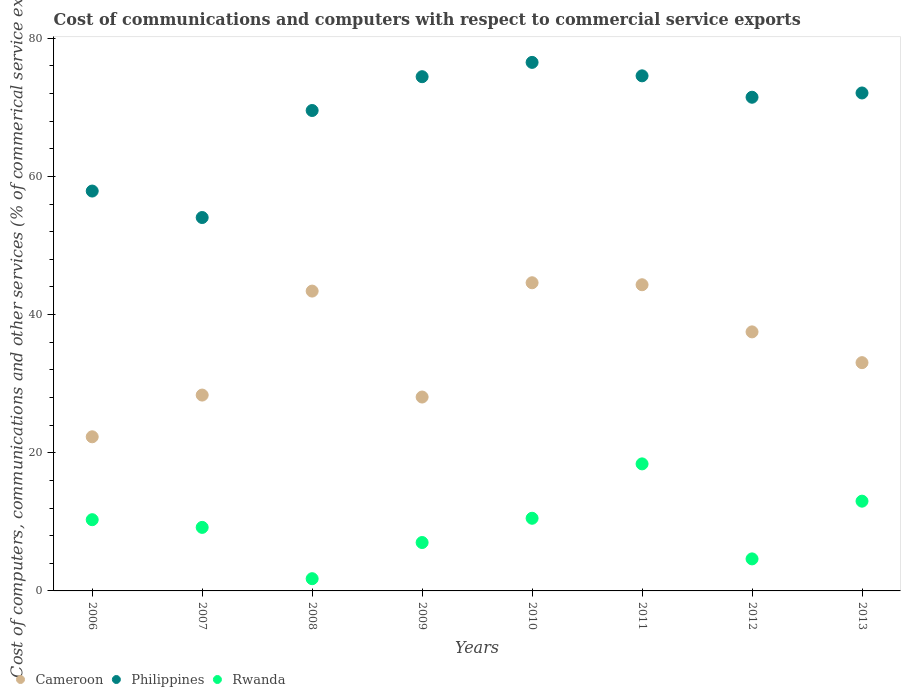What is the cost of communications and computers in Philippines in 2013?
Your answer should be compact. 72.08. Across all years, what is the maximum cost of communications and computers in Rwanda?
Offer a very short reply. 18.39. Across all years, what is the minimum cost of communications and computers in Cameroon?
Give a very brief answer. 22.31. In which year was the cost of communications and computers in Rwanda maximum?
Keep it short and to the point. 2011. What is the total cost of communications and computers in Rwanda in the graph?
Give a very brief answer. 74.81. What is the difference between the cost of communications and computers in Cameroon in 2011 and that in 2013?
Your response must be concise. 11.28. What is the difference between the cost of communications and computers in Philippines in 2011 and the cost of communications and computers in Cameroon in 2007?
Provide a short and direct response. 46.21. What is the average cost of communications and computers in Philippines per year?
Your response must be concise. 68.81. In the year 2011, what is the difference between the cost of communications and computers in Rwanda and cost of communications and computers in Philippines?
Provide a succinct answer. -56.17. What is the ratio of the cost of communications and computers in Philippines in 2006 to that in 2010?
Provide a short and direct response. 0.76. What is the difference between the highest and the second highest cost of communications and computers in Cameroon?
Your answer should be very brief. 0.29. What is the difference between the highest and the lowest cost of communications and computers in Rwanda?
Make the answer very short. 16.62. In how many years, is the cost of communications and computers in Rwanda greater than the average cost of communications and computers in Rwanda taken over all years?
Your response must be concise. 4. Is the sum of the cost of communications and computers in Philippines in 2009 and 2013 greater than the maximum cost of communications and computers in Cameroon across all years?
Ensure brevity in your answer.  Yes. Does the cost of communications and computers in Philippines monotonically increase over the years?
Your answer should be compact. No. Is the cost of communications and computers in Cameroon strictly less than the cost of communications and computers in Philippines over the years?
Your answer should be compact. Yes. What is the difference between two consecutive major ticks on the Y-axis?
Make the answer very short. 20. Does the graph contain any zero values?
Your answer should be compact. No. What is the title of the graph?
Your answer should be compact. Cost of communications and computers with respect to commercial service exports. Does "Low & middle income" appear as one of the legend labels in the graph?
Offer a terse response. No. What is the label or title of the Y-axis?
Ensure brevity in your answer.  Cost of computers, communications and other services (% of commerical service exports). What is the Cost of computers, communications and other services (% of commerical service exports) of Cameroon in 2006?
Offer a terse response. 22.31. What is the Cost of computers, communications and other services (% of commerical service exports) in Philippines in 2006?
Keep it short and to the point. 57.88. What is the Cost of computers, communications and other services (% of commerical service exports) in Rwanda in 2006?
Make the answer very short. 10.31. What is the Cost of computers, communications and other services (% of commerical service exports) in Cameroon in 2007?
Offer a very short reply. 28.35. What is the Cost of computers, communications and other services (% of commerical service exports) in Philippines in 2007?
Offer a very short reply. 54.05. What is the Cost of computers, communications and other services (% of commerical service exports) in Rwanda in 2007?
Keep it short and to the point. 9.2. What is the Cost of computers, communications and other services (% of commerical service exports) in Cameroon in 2008?
Your answer should be very brief. 43.4. What is the Cost of computers, communications and other services (% of commerical service exports) of Philippines in 2008?
Offer a very short reply. 69.54. What is the Cost of computers, communications and other services (% of commerical service exports) in Rwanda in 2008?
Your answer should be compact. 1.77. What is the Cost of computers, communications and other services (% of commerical service exports) in Cameroon in 2009?
Make the answer very short. 28.06. What is the Cost of computers, communications and other services (% of commerical service exports) in Philippines in 2009?
Give a very brief answer. 74.43. What is the Cost of computers, communications and other services (% of commerical service exports) in Rwanda in 2009?
Offer a terse response. 7.01. What is the Cost of computers, communications and other services (% of commerical service exports) in Cameroon in 2010?
Keep it short and to the point. 44.61. What is the Cost of computers, communications and other services (% of commerical service exports) in Philippines in 2010?
Keep it short and to the point. 76.5. What is the Cost of computers, communications and other services (% of commerical service exports) in Rwanda in 2010?
Offer a very short reply. 10.52. What is the Cost of computers, communications and other services (% of commerical service exports) of Cameroon in 2011?
Your response must be concise. 44.32. What is the Cost of computers, communications and other services (% of commerical service exports) of Philippines in 2011?
Your answer should be very brief. 74.56. What is the Cost of computers, communications and other services (% of commerical service exports) in Rwanda in 2011?
Offer a terse response. 18.39. What is the Cost of computers, communications and other services (% of commerical service exports) in Cameroon in 2012?
Give a very brief answer. 37.5. What is the Cost of computers, communications and other services (% of commerical service exports) in Philippines in 2012?
Provide a short and direct response. 71.46. What is the Cost of computers, communications and other services (% of commerical service exports) in Rwanda in 2012?
Provide a succinct answer. 4.64. What is the Cost of computers, communications and other services (% of commerical service exports) in Cameroon in 2013?
Provide a short and direct response. 33.04. What is the Cost of computers, communications and other services (% of commerical service exports) of Philippines in 2013?
Ensure brevity in your answer.  72.08. What is the Cost of computers, communications and other services (% of commerical service exports) of Rwanda in 2013?
Offer a terse response. 12.99. Across all years, what is the maximum Cost of computers, communications and other services (% of commerical service exports) in Cameroon?
Provide a short and direct response. 44.61. Across all years, what is the maximum Cost of computers, communications and other services (% of commerical service exports) of Philippines?
Make the answer very short. 76.5. Across all years, what is the maximum Cost of computers, communications and other services (% of commerical service exports) of Rwanda?
Provide a short and direct response. 18.39. Across all years, what is the minimum Cost of computers, communications and other services (% of commerical service exports) of Cameroon?
Keep it short and to the point. 22.31. Across all years, what is the minimum Cost of computers, communications and other services (% of commerical service exports) of Philippines?
Your response must be concise. 54.05. Across all years, what is the minimum Cost of computers, communications and other services (% of commerical service exports) of Rwanda?
Provide a short and direct response. 1.77. What is the total Cost of computers, communications and other services (% of commerical service exports) in Cameroon in the graph?
Offer a terse response. 281.59. What is the total Cost of computers, communications and other services (% of commerical service exports) of Philippines in the graph?
Your answer should be compact. 550.5. What is the total Cost of computers, communications and other services (% of commerical service exports) in Rwanda in the graph?
Offer a terse response. 74.81. What is the difference between the Cost of computers, communications and other services (% of commerical service exports) in Cameroon in 2006 and that in 2007?
Give a very brief answer. -6.04. What is the difference between the Cost of computers, communications and other services (% of commerical service exports) in Philippines in 2006 and that in 2007?
Ensure brevity in your answer.  3.83. What is the difference between the Cost of computers, communications and other services (% of commerical service exports) of Rwanda in 2006 and that in 2007?
Make the answer very short. 1.11. What is the difference between the Cost of computers, communications and other services (% of commerical service exports) of Cameroon in 2006 and that in 2008?
Keep it short and to the point. -21.09. What is the difference between the Cost of computers, communications and other services (% of commerical service exports) in Philippines in 2006 and that in 2008?
Keep it short and to the point. -11.66. What is the difference between the Cost of computers, communications and other services (% of commerical service exports) in Rwanda in 2006 and that in 2008?
Ensure brevity in your answer.  8.54. What is the difference between the Cost of computers, communications and other services (% of commerical service exports) of Cameroon in 2006 and that in 2009?
Provide a short and direct response. -5.75. What is the difference between the Cost of computers, communications and other services (% of commerical service exports) of Philippines in 2006 and that in 2009?
Provide a short and direct response. -16.55. What is the difference between the Cost of computers, communications and other services (% of commerical service exports) of Rwanda in 2006 and that in 2009?
Keep it short and to the point. 3.3. What is the difference between the Cost of computers, communications and other services (% of commerical service exports) of Cameroon in 2006 and that in 2010?
Give a very brief answer. -22.3. What is the difference between the Cost of computers, communications and other services (% of commerical service exports) in Philippines in 2006 and that in 2010?
Your answer should be compact. -18.62. What is the difference between the Cost of computers, communications and other services (% of commerical service exports) in Rwanda in 2006 and that in 2010?
Offer a terse response. -0.21. What is the difference between the Cost of computers, communications and other services (% of commerical service exports) in Cameroon in 2006 and that in 2011?
Give a very brief answer. -22.01. What is the difference between the Cost of computers, communications and other services (% of commerical service exports) of Philippines in 2006 and that in 2011?
Provide a short and direct response. -16.68. What is the difference between the Cost of computers, communications and other services (% of commerical service exports) in Rwanda in 2006 and that in 2011?
Keep it short and to the point. -8.08. What is the difference between the Cost of computers, communications and other services (% of commerical service exports) in Cameroon in 2006 and that in 2012?
Provide a succinct answer. -15.19. What is the difference between the Cost of computers, communications and other services (% of commerical service exports) of Philippines in 2006 and that in 2012?
Your response must be concise. -13.58. What is the difference between the Cost of computers, communications and other services (% of commerical service exports) in Rwanda in 2006 and that in 2012?
Make the answer very short. 5.67. What is the difference between the Cost of computers, communications and other services (% of commerical service exports) in Cameroon in 2006 and that in 2013?
Provide a succinct answer. -10.73. What is the difference between the Cost of computers, communications and other services (% of commerical service exports) in Philippines in 2006 and that in 2013?
Your answer should be compact. -14.2. What is the difference between the Cost of computers, communications and other services (% of commerical service exports) in Rwanda in 2006 and that in 2013?
Provide a short and direct response. -2.68. What is the difference between the Cost of computers, communications and other services (% of commerical service exports) in Cameroon in 2007 and that in 2008?
Make the answer very short. -15.05. What is the difference between the Cost of computers, communications and other services (% of commerical service exports) in Philippines in 2007 and that in 2008?
Your answer should be compact. -15.49. What is the difference between the Cost of computers, communications and other services (% of commerical service exports) of Rwanda in 2007 and that in 2008?
Keep it short and to the point. 7.43. What is the difference between the Cost of computers, communications and other services (% of commerical service exports) in Cameroon in 2007 and that in 2009?
Your response must be concise. 0.28. What is the difference between the Cost of computers, communications and other services (% of commerical service exports) in Philippines in 2007 and that in 2009?
Offer a very short reply. -20.38. What is the difference between the Cost of computers, communications and other services (% of commerical service exports) in Rwanda in 2007 and that in 2009?
Make the answer very short. 2.19. What is the difference between the Cost of computers, communications and other services (% of commerical service exports) in Cameroon in 2007 and that in 2010?
Make the answer very short. -16.26. What is the difference between the Cost of computers, communications and other services (% of commerical service exports) in Philippines in 2007 and that in 2010?
Your answer should be very brief. -22.46. What is the difference between the Cost of computers, communications and other services (% of commerical service exports) in Rwanda in 2007 and that in 2010?
Offer a very short reply. -1.32. What is the difference between the Cost of computers, communications and other services (% of commerical service exports) of Cameroon in 2007 and that in 2011?
Ensure brevity in your answer.  -15.97. What is the difference between the Cost of computers, communications and other services (% of commerical service exports) of Philippines in 2007 and that in 2011?
Provide a short and direct response. -20.51. What is the difference between the Cost of computers, communications and other services (% of commerical service exports) in Rwanda in 2007 and that in 2011?
Provide a succinct answer. -9.19. What is the difference between the Cost of computers, communications and other services (% of commerical service exports) of Cameroon in 2007 and that in 2012?
Your answer should be very brief. -9.15. What is the difference between the Cost of computers, communications and other services (% of commerical service exports) of Philippines in 2007 and that in 2012?
Keep it short and to the point. -17.41. What is the difference between the Cost of computers, communications and other services (% of commerical service exports) in Rwanda in 2007 and that in 2012?
Your answer should be compact. 4.56. What is the difference between the Cost of computers, communications and other services (% of commerical service exports) in Cameroon in 2007 and that in 2013?
Give a very brief answer. -4.69. What is the difference between the Cost of computers, communications and other services (% of commerical service exports) of Philippines in 2007 and that in 2013?
Your response must be concise. -18.03. What is the difference between the Cost of computers, communications and other services (% of commerical service exports) of Rwanda in 2007 and that in 2013?
Your response must be concise. -3.8. What is the difference between the Cost of computers, communications and other services (% of commerical service exports) of Cameroon in 2008 and that in 2009?
Provide a short and direct response. 15.34. What is the difference between the Cost of computers, communications and other services (% of commerical service exports) in Philippines in 2008 and that in 2009?
Provide a short and direct response. -4.89. What is the difference between the Cost of computers, communications and other services (% of commerical service exports) of Rwanda in 2008 and that in 2009?
Offer a terse response. -5.24. What is the difference between the Cost of computers, communications and other services (% of commerical service exports) of Cameroon in 2008 and that in 2010?
Your response must be concise. -1.21. What is the difference between the Cost of computers, communications and other services (% of commerical service exports) of Philippines in 2008 and that in 2010?
Make the answer very short. -6.96. What is the difference between the Cost of computers, communications and other services (% of commerical service exports) in Rwanda in 2008 and that in 2010?
Ensure brevity in your answer.  -8.75. What is the difference between the Cost of computers, communications and other services (% of commerical service exports) in Cameroon in 2008 and that in 2011?
Provide a succinct answer. -0.92. What is the difference between the Cost of computers, communications and other services (% of commerical service exports) of Philippines in 2008 and that in 2011?
Your answer should be very brief. -5.02. What is the difference between the Cost of computers, communications and other services (% of commerical service exports) in Rwanda in 2008 and that in 2011?
Make the answer very short. -16.62. What is the difference between the Cost of computers, communications and other services (% of commerical service exports) in Cameroon in 2008 and that in 2012?
Make the answer very short. 5.9. What is the difference between the Cost of computers, communications and other services (% of commerical service exports) of Philippines in 2008 and that in 2012?
Offer a very short reply. -1.92. What is the difference between the Cost of computers, communications and other services (% of commerical service exports) of Rwanda in 2008 and that in 2012?
Your answer should be compact. -2.87. What is the difference between the Cost of computers, communications and other services (% of commerical service exports) of Cameroon in 2008 and that in 2013?
Give a very brief answer. 10.36. What is the difference between the Cost of computers, communications and other services (% of commerical service exports) of Philippines in 2008 and that in 2013?
Your response must be concise. -2.54. What is the difference between the Cost of computers, communications and other services (% of commerical service exports) of Rwanda in 2008 and that in 2013?
Offer a very short reply. -11.22. What is the difference between the Cost of computers, communications and other services (% of commerical service exports) of Cameroon in 2009 and that in 2010?
Keep it short and to the point. -16.54. What is the difference between the Cost of computers, communications and other services (% of commerical service exports) in Philippines in 2009 and that in 2010?
Make the answer very short. -2.07. What is the difference between the Cost of computers, communications and other services (% of commerical service exports) of Rwanda in 2009 and that in 2010?
Provide a succinct answer. -3.51. What is the difference between the Cost of computers, communications and other services (% of commerical service exports) of Cameroon in 2009 and that in 2011?
Give a very brief answer. -16.25. What is the difference between the Cost of computers, communications and other services (% of commerical service exports) in Philippines in 2009 and that in 2011?
Offer a terse response. -0.12. What is the difference between the Cost of computers, communications and other services (% of commerical service exports) in Rwanda in 2009 and that in 2011?
Make the answer very short. -11.38. What is the difference between the Cost of computers, communications and other services (% of commerical service exports) of Cameroon in 2009 and that in 2012?
Give a very brief answer. -9.43. What is the difference between the Cost of computers, communications and other services (% of commerical service exports) in Philippines in 2009 and that in 2012?
Give a very brief answer. 2.97. What is the difference between the Cost of computers, communications and other services (% of commerical service exports) of Rwanda in 2009 and that in 2012?
Your answer should be compact. 2.37. What is the difference between the Cost of computers, communications and other services (% of commerical service exports) in Cameroon in 2009 and that in 2013?
Keep it short and to the point. -4.98. What is the difference between the Cost of computers, communications and other services (% of commerical service exports) of Philippines in 2009 and that in 2013?
Provide a short and direct response. 2.36. What is the difference between the Cost of computers, communications and other services (% of commerical service exports) in Rwanda in 2009 and that in 2013?
Provide a succinct answer. -5.99. What is the difference between the Cost of computers, communications and other services (% of commerical service exports) in Cameroon in 2010 and that in 2011?
Give a very brief answer. 0.29. What is the difference between the Cost of computers, communications and other services (% of commerical service exports) in Philippines in 2010 and that in 2011?
Provide a short and direct response. 1.95. What is the difference between the Cost of computers, communications and other services (% of commerical service exports) of Rwanda in 2010 and that in 2011?
Give a very brief answer. -7.87. What is the difference between the Cost of computers, communications and other services (% of commerical service exports) of Cameroon in 2010 and that in 2012?
Keep it short and to the point. 7.11. What is the difference between the Cost of computers, communications and other services (% of commerical service exports) in Philippines in 2010 and that in 2012?
Make the answer very short. 5.04. What is the difference between the Cost of computers, communications and other services (% of commerical service exports) in Rwanda in 2010 and that in 2012?
Make the answer very short. 5.88. What is the difference between the Cost of computers, communications and other services (% of commerical service exports) in Cameroon in 2010 and that in 2013?
Provide a short and direct response. 11.57. What is the difference between the Cost of computers, communications and other services (% of commerical service exports) of Philippines in 2010 and that in 2013?
Offer a terse response. 4.43. What is the difference between the Cost of computers, communications and other services (% of commerical service exports) of Rwanda in 2010 and that in 2013?
Your answer should be very brief. -2.48. What is the difference between the Cost of computers, communications and other services (% of commerical service exports) in Cameroon in 2011 and that in 2012?
Your answer should be compact. 6.82. What is the difference between the Cost of computers, communications and other services (% of commerical service exports) of Philippines in 2011 and that in 2012?
Keep it short and to the point. 3.1. What is the difference between the Cost of computers, communications and other services (% of commerical service exports) of Rwanda in 2011 and that in 2012?
Your response must be concise. 13.75. What is the difference between the Cost of computers, communications and other services (% of commerical service exports) of Cameroon in 2011 and that in 2013?
Ensure brevity in your answer.  11.28. What is the difference between the Cost of computers, communications and other services (% of commerical service exports) of Philippines in 2011 and that in 2013?
Give a very brief answer. 2.48. What is the difference between the Cost of computers, communications and other services (% of commerical service exports) of Rwanda in 2011 and that in 2013?
Provide a succinct answer. 5.4. What is the difference between the Cost of computers, communications and other services (% of commerical service exports) in Cameroon in 2012 and that in 2013?
Provide a short and direct response. 4.45. What is the difference between the Cost of computers, communications and other services (% of commerical service exports) of Philippines in 2012 and that in 2013?
Your answer should be compact. -0.62. What is the difference between the Cost of computers, communications and other services (% of commerical service exports) of Rwanda in 2012 and that in 2013?
Provide a short and direct response. -8.36. What is the difference between the Cost of computers, communications and other services (% of commerical service exports) in Cameroon in 2006 and the Cost of computers, communications and other services (% of commerical service exports) in Philippines in 2007?
Ensure brevity in your answer.  -31.74. What is the difference between the Cost of computers, communications and other services (% of commerical service exports) in Cameroon in 2006 and the Cost of computers, communications and other services (% of commerical service exports) in Rwanda in 2007?
Provide a short and direct response. 13.11. What is the difference between the Cost of computers, communications and other services (% of commerical service exports) in Philippines in 2006 and the Cost of computers, communications and other services (% of commerical service exports) in Rwanda in 2007?
Ensure brevity in your answer.  48.68. What is the difference between the Cost of computers, communications and other services (% of commerical service exports) in Cameroon in 2006 and the Cost of computers, communications and other services (% of commerical service exports) in Philippines in 2008?
Your answer should be compact. -47.23. What is the difference between the Cost of computers, communications and other services (% of commerical service exports) of Cameroon in 2006 and the Cost of computers, communications and other services (% of commerical service exports) of Rwanda in 2008?
Provide a succinct answer. 20.54. What is the difference between the Cost of computers, communications and other services (% of commerical service exports) in Philippines in 2006 and the Cost of computers, communications and other services (% of commerical service exports) in Rwanda in 2008?
Your answer should be compact. 56.11. What is the difference between the Cost of computers, communications and other services (% of commerical service exports) of Cameroon in 2006 and the Cost of computers, communications and other services (% of commerical service exports) of Philippines in 2009?
Keep it short and to the point. -52.12. What is the difference between the Cost of computers, communications and other services (% of commerical service exports) of Cameroon in 2006 and the Cost of computers, communications and other services (% of commerical service exports) of Rwanda in 2009?
Provide a short and direct response. 15.3. What is the difference between the Cost of computers, communications and other services (% of commerical service exports) of Philippines in 2006 and the Cost of computers, communications and other services (% of commerical service exports) of Rwanda in 2009?
Offer a terse response. 50.88. What is the difference between the Cost of computers, communications and other services (% of commerical service exports) of Cameroon in 2006 and the Cost of computers, communications and other services (% of commerical service exports) of Philippines in 2010?
Keep it short and to the point. -54.19. What is the difference between the Cost of computers, communications and other services (% of commerical service exports) in Cameroon in 2006 and the Cost of computers, communications and other services (% of commerical service exports) in Rwanda in 2010?
Make the answer very short. 11.79. What is the difference between the Cost of computers, communications and other services (% of commerical service exports) in Philippines in 2006 and the Cost of computers, communications and other services (% of commerical service exports) in Rwanda in 2010?
Provide a succinct answer. 47.36. What is the difference between the Cost of computers, communications and other services (% of commerical service exports) in Cameroon in 2006 and the Cost of computers, communications and other services (% of commerical service exports) in Philippines in 2011?
Offer a terse response. -52.25. What is the difference between the Cost of computers, communications and other services (% of commerical service exports) of Cameroon in 2006 and the Cost of computers, communications and other services (% of commerical service exports) of Rwanda in 2011?
Your response must be concise. 3.92. What is the difference between the Cost of computers, communications and other services (% of commerical service exports) of Philippines in 2006 and the Cost of computers, communications and other services (% of commerical service exports) of Rwanda in 2011?
Ensure brevity in your answer.  39.49. What is the difference between the Cost of computers, communications and other services (% of commerical service exports) of Cameroon in 2006 and the Cost of computers, communications and other services (% of commerical service exports) of Philippines in 2012?
Your answer should be compact. -49.15. What is the difference between the Cost of computers, communications and other services (% of commerical service exports) in Cameroon in 2006 and the Cost of computers, communications and other services (% of commerical service exports) in Rwanda in 2012?
Your answer should be compact. 17.67. What is the difference between the Cost of computers, communications and other services (% of commerical service exports) of Philippines in 2006 and the Cost of computers, communications and other services (% of commerical service exports) of Rwanda in 2012?
Provide a succinct answer. 53.24. What is the difference between the Cost of computers, communications and other services (% of commerical service exports) of Cameroon in 2006 and the Cost of computers, communications and other services (% of commerical service exports) of Philippines in 2013?
Ensure brevity in your answer.  -49.77. What is the difference between the Cost of computers, communications and other services (% of commerical service exports) in Cameroon in 2006 and the Cost of computers, communications and other services (% of commerical service exports) in Rwanda in 2013?
Your answer should be very brief. 9.32. What is the difference between the Cost of computers, communications and other services (% of commerical service exports) in Philippines in 2006 and the Cost of computers, communications and other services (% of commerical service exports) in Rwanda in 2013?
Give a very brief answer. 44.89. What is the difference between the Cost of computers, communications and other services (% of commerical service exports) of Cameroon in 2007 and the Cost of computers, communications and other services (% of commerical service exports) of Philippines in 2008?
Your answer should be compact. -41.19. What is the difference between the Cost of computers, communications and other services (% of commerical service exports) in Cameroon in 2007 and the Cost of computers, communications and other services (% of commerical service exports) in Rwanda in 2008?
Your answer should be very brief. 26.58. What is the difference between the Cost of computers, communications and other services (% of commerical service exports) in Philippines in 2007 and the Cost of computers, communications and other services (% of commerical service exports) in Rwanda in 2008?
Make the answer very short. 52.28. What is the difference between the Cost of computers, communications and other services (% of commerical service exports) in Cameroon in 2007 and the Cost of computers, communications and other services (% of commerical service exports) in Philippines in 2009?
Provide a succinct answer. -46.08. What is the difference between the Cost of computers, communications and other services (% of commerical service exports) of Cameroon in 2007 and the Cost of computers, communications and other services (% of commerical service exports) of Rwanda in 2009?
Keep it short and to the point. 21.34. What is the difference between the Cost of computers, communications and other services (% of commerical service exports) in Philippines in 2007 and the Cost of computers, communications and other services (% of commerical service exports) in Rwanda in 2009?
Provide a succinct answer. 47.04. What is the difference between the Cost of computers, communications and other services (% of commerical service exports) in Cameroon in 2007 and the Cost of computers, communications and other services (% of commerical service exports) in Philippines in 2010?
Offer a terse response. -48.16. What is the difference between the Cost of computers, communications and other services (% of commerical service exports) of Cameroon in 2007 and the Cost of computers, communications and other services (% of commerical service exports) of Rwanda in 2010?
Your response must be concise. 17.83. What is the difference between the Cost of computers, communications and other services (% of commerical service exports) in Philippines in 2007 and the Cost of computers, communications and other services (% of commerical service exports) in Rwanda in 2010?
Keep it short and to the point. 43.53. What is the difference between the Cost of computers, communications and other services (% of commerical service exports) in Cameroon in 2007 and the Cost of computers, communications and other services (% of commerical service exports) in Philippines in 2011?
Your answer should be compact. -46.21. What is the difference between the Cost of computers, communications and other services (% of commerical service exports) in Cameroon in 2007 and the Cost of computers, communications and other services (% of commerical service exports) in Rwanda in 2011?
Ensure brevity in your answer.  9.96. What is the difference between the Cost of computers, communications and other services (% of commerical service exports) in Philippines in 2007 and the Cost of computers, communications and other services (% of commerical service exports) in Rwanda in 2011?
Make the answer very short. 35.66. What is the difference between the Cost of computers, communications and other services (% of commerical service exports) of Cameroon in 2007 and the Cost of computers, communications and other services (% of commerical service exports) of Philippines in 2012?
Ensure brevity in your answer.  -43.11. What is the difference between the Cost of computers, communications and other services (% of commerical service exports) in Cameroon in 2007 and the Cost of computers, communications and other services (% of commerical service exports) in Rwanda in 2012?
Your response must be concise. 23.71. What is the difference between the Cost of computers, communications and other services (% of commerical service exports) of Philippines in 2007 and the Cost of computers, communications and other services (% of commerical service exports) of Rwanda in 2012?
Offer a very short reply. 49.41. What is the difference between the Cost of computers, communications and other services (% of commerical service exports) of Cameroon in 2007 and the Cost of computers, communications and other services (% of commerical service exports) of Philippines in 2013?
Your answer should be compact. -43.73. What is the difference between the Cost of computers, communications and other services (% of commerical service exports) of Cameroon in 2007 and the Cost of computers, communications and other services (% of commerical service exports) of Rwanda in 2013?
Your answer should be compact. 15.36. What is the difference between the Cost of computers, communications and other services (% of commerical service exports) of Philippines in 2007 and the Cost of computers, communications and other services (% of commerical service exports) of Rwanda in 2013?
Your response must be concise. 41.06. What is the difference between the Cost of computers, communications and other services (% of commerical service exports) of Cameroon in 2008 and the Cost of computers, communications and other services (% of commerical service exports) of Philippines in 2009?
Ensure brevity in your answer.  -31.03. What is the difference between the Cost of computers, communications and other services (% of commerical service exports) of Cameroon in 2008 and the Cost of computers, communications and other services (% of commerical service exports) of Rwanda in 2009?
Your answer should be compact. 36.39. What is the difference between the Cost of computers, communications and other services (% of commerical service exports) in Philippines in 2008 and the Cost of computers, communications and other services (% of commerical service exports) in Rwanda in 2009?
Give a very brief answer. 62.53. What is the difference between the Cost of computers, communications and other services (% of commerical service exports) of Cameroon in 2008 and the Cost of computers, communications and other services (% of commerical service exports) of Philippines in 2010?
Your response must be concise. -33.1. What is the difference between the Cost of computers, communications and other services (% of commerical service exports) of Cameroon in 2008 and the Cost of computers, communications and other services (% of commerical service exports) of Rwanda in 2010?
Give a very brief answer. 32.88. What is the difference between the Cost of computers, communications and other services (% of commerical service exports) in Philippines in 2008 and the Cost of computers, communications and other services (% of commerical service exports) in Rwanda in 2010?
Ensure brevity in your answer.  59.02. What is the difference between the Cost of computers, communications and other services (% of commerical service exports) of Cameroon in 2008 and the Cost of computers, communications and other services (% of commerical service exports) of Philippines in 2011?
Your answer should be very brief. -31.16. What is the difference between the Cost of computers, communications and other services (% of commerical service exports) in Cameroon in 2008 and the Cost of computers, communications and other services (% of commerical service exports) in Rwanda in 2011?
Your answer should be compact. 25.01. What is the difference between the Cost of computers, communications and other services (% of commerical service exports) of Philippines in 2008 and the Cost of computers, communications and other services (% of commerical service exports) of Rwanda in 2011?
Provide a succinct answer. 51.15. What is the difference between the Cost of computers, communications and other services (% of commerical service exports) in Cameroon in 2008 and the Cost of computers, communications and other services (% of commerical service exports) in Philippines in 2012?
Offer a very short reply. -28.06. What is the difference between the Cost of computers, communications and other services (% of commerical service exports) of Cameroon in 2008 and the Cost of computers, communications and other services (% of commerical service exports) of Rwanda in 2012?
Your response must be concise. 38.76. What is the difference between the Cost of computers, communications and other services (% of commerical service exports) in Philippines in 2008 and the Cost of computers, communications and other services (% of commerical service exports) in Rwanda in 2012?
Keep it short and to the point. 64.9. What is the difference between the Cost of computers, communications and other services (% of commerical service exports) in Cameroon in 2008 and the Cost of computers, communications and other services (% of commerical service exports) in Philippines in 2013?
Give a very brief answer. -28.68. What is the difference between the Cost of computers, communications and other services (% of commerical service exports) in Cameroon in 2008 and the Cost of computers, communications and other services (% of commerical service exports) in Rwanda in 2013?
Your answer should be compact. 30.41. What is the difference between the Cost of computers, communications and other services (% of commerical service exports) in Philippines in 2008 and the Cost of computers, communications and other services (% of commerical service exports) in Rwanda in 2013?
Offer a very short reply. 56.55. What is the difference between the Cost of computers, communications and other services (% of commerical service exports) of Cameroon in 2009 and the Cost of computers, communications and other services (% of commerical service exports) of Philippines in 2010?
Your answer should be very brief. -48.44. What is the difference between the Cost of computers, communications and other services (% of commerical service exports) in Cameroon in 2009 and the Cost of computers, communications and other services (% of commerical service exports) in Rwanda in 2010?
Offer a very short reply. 17.55. What is the difference between the Cost of computers, communications and other services (% of commerical service exports) of Philippines in 2009 and the Cost of computers, communications and other services (% of commerical service exports) of Rwanda in 2010?
Offer a terse response. 63.92. What is the difference between the Cost of computers, communications and other services (% of commerical service exports) of Cameroon in 2009 and the Cost of computers, communications and other services (% of commerical service exports) of Philippines in 2011?
Your answer should be very brief. -46.49. What is the difference between the Cost of computers, communications and other services (% of commerical service exports) of Cameroon in 2009 and the Cost of computers, communications and other services (% of commerical service exports) of Rwanda in 2011?
Ensure brevity in your answer.  9.68. What is the difference between the Cost of computers, communications and other services (% of commerical service exports) of Philippines in 2009 and the Cost of computers, communications and other services (% of commerical service exports) of Rwanda in 2011?
Offer a terse response. 56.04. What is the difference between the Cost of computers, communications and other services (% of commerical service exports) of Cameroon in 2009 and the Cost of computers, communications and other services (% of commerical service exports) of Philippines in 2012?
Keep it short and to the point. -43.4. What is the difference between the Cost of computers, communications and other services (% of commerical service exports) of Cameroon in 2009 and the Cost of computers, communications and other services (% of commerical service exports) of Rwanda in 2012?
Your answer should be compact. 23.43. What is the difference between the Cost of computers, communications and other services (% of commerical service exports) in Philippines in 2009 and the Cost of computers, communications and other services (% of commerical service exports) in Rwanda in 2012?
Give a very brief answer. 69.8. What is the difference between the Cost of computers, communications and other services (% of commerical service exports) in Cameroon in 2009 and the Cost of computers, communications and other services (% of commerical service exports) in Philippines in 2013?
Your answer should be very brief. -44.01. What is the difference between the Cost of computers, communications and other services (% of commerical service exports) in Cameroon in 2009 and the Cost of computers, communications and other services (% of commerical service exports) in Rwanda in 2013?
Offer a terse response. 15.07. What is the difference between the Cost of computers, communications and other services (% of commerical service exports) of Philippines in 2009 and the Cost of computers, communications and other services (% of commerical service exports) of Rwanda in 2013?
Offer a very short reply. 61.44. What is the difference between the Cost of computers, communications and other services (% of commerical service exports) of Cameroon in 2010 and the Cost of computers, communications and other services (% of commerical service exports) of Philippines in 2011?
Offer a terse response. -29.95. What is the difference between the Cost of computers, communications and other services (% of commerical service exports) in Cameroon in 2010 and the Cost of computers, communications and other services (% of commerical service exports) in Rwanda in 2011?
Provide a short and direct response. 26.22. What is the difference between the Cost of computers, communications and other services (% of commerical service exports) in Philippines in 2010 and the Cost of computers, communications and other services (% of commerical service exports) in Rwanda in 2011?
Provide a short and direct response. 58.12. What is the difference between the Cost of computers, communications and other services (% of commerical service exports) in Cameroon in 2010 and the Cost of computers, communications and other services (% of commerical service exports) in Philippines in 2012?
Provide a short and direct response. -26.85. What is the difference between the Cost of computers, communications and other services (% of commerical service exports) in Cameroon in 2010 and the Cost of computers, communications and other services (% of commerical service exports) in Rwanda in 2012?
Offer a very short reply. 39.97. What is the difference between the Cost of computers, communications and other services (% of commerical service exports) in Philippines in 2010 and the Cost of computers, communications and other services (% of commerical service exports) in Rwanda in 2012?
Your response must be concise. 71.87. What is the difference between the Cost of computers, communications and other services (% of commerical service exports) of Cameroon in 2010 and the Cost of computers, communications and other services (% of commerical service exports) of Philippines in 2013?
Provide a succinct answer. -27.47. What is the difference between the Cost of computers, communications and other services (% of commerical service exports) in Cameroon in 2010 and the Cost of computers, communications and other services (% of commerical service exports) in Rwanda in 2013?
Your response must be concise. 31.61. What is the difference between the Cost of computers, communications and other services (% of commerical service exports) of Philippines in 2010 and the Cost of computers, communications and other services (% of commerical service exports) of Rwanda in 2013?
Provide a short and direct response. 63.51. What is the difference between the Cost of computers, communications and other services (% of commerical service exports) of Cameroon in 2011 and the Cost of computers, communications and other services (% of commerical service exports) of Philippines in 2012?
Keep it short and to the point. -27.14. What is the difference between the Cost of computers, communications and other services (% of commerical service exports) in Cameroon in 2011 and the Cost of computers, communications and other services (% of commerical service exports) in Rwanda in 2012?
Your answer should be very brief. 39.68. What is the difference between the Cost of computers, communications and other services (% of commerical service exports) of Philippines in 2011 and the Cost of computers, communications and other services (% of commerical service exports) of Rwanda in 2012?
Offer a very short reply. 69.92. What is the difference between the Cost of computers, communications and other services (% of commerical service exports) in Cameroon in 2011 and the Cost of computers, communications and other services (% of commerical service exports) in Philippines in 2013?
Offer a terse response. -27.76. What is the difference between the Cost of computers, communications and other services (% of commerical service exports) in Cameroon in 2011 and the Cost of computers, communications and other services (% of commerical service exports) in Rwanda in 2013?
Provide a short and direct response. 31.33. What is the difference between the Cost of computers, communications and other services (% of commerical service exports) in Philippines in 2011 and the Cost of computers, communications and other services (% of commerical service exports) in Rwanda in 2013?
Your answer should be compact. 61.57. What is the difference between the Cost of computers, communications and other services (% of commerical service exports) of Cameroon in 2012 and the Cost of computers, communications and other services (% of commerical service exports) of Philippines in 2013?
Keep it short and to the point. -34.58. What is the difference between the Cost of computers, communications and other services (% of commerical service exports) of Cameroon in 2012 and the Cost of computers, communications and other services (% of commerical service exports) of Rwanda in 2013?
Your answer should be compact. 24.5. What is the difference between the Cost of computers, communications and other services (% of commerical service exports) in Philippines in 2012 and the Cost of computers, communications and other services (% of commerical service exports) in Rwanda in 2013?
Provide a short and direct response. 58.47. What is the average Cost of computers, communications and other services (% of commerical service exports) of Cameroon per year?
Provide a succinct answer. 35.2. What is the average Cost of computers, communications and other services (% of commerical service exports) of Philippines per year?
Provide a short and direct response. 68.81. What is the average Cost of computers, communications and other services (% of commerical service exports) in Rwanda per year?
Offer a terse response. 9.35. In the year 2006, what is the difference between the Cost of computers, communications and other services (% of commerical service exports) in Cameroon and Cost of computers, communications and other services (% of commerical service exports) in Philippines?
Make the answer very short. -35.57. In the year 2006, what is the difference between the Cost of computers, communications and other services (% of commerical service exports) in Cameroon and Cost of computers, communications and other services (% of commerical service exports) in Rwanda?
Offer a terse response. 12. In the year 2006, what is the difference between the Cost of computers, communications and other services (% of commerical service exports) of Philippines and Cost of computers, communications and other services (% of commerical service exports) of Rwanda?
Give a very brief answer. 47.57. In the year 2007, what is the difference between the Cost of computers, communications and other services (% of commerical service exports) in Cameroon and Cost of computers, communications and other services (% of commerical service exports) in Philippines?
Make the answer very short. -25.7. In the year 2007, what is the difference between the Cost of computers, communications and other services (% of commerical service exports) in Cameroon and Cost of computers, communications and other services (% of commerical service exports) in Rwanda?
Make the answer very short. 19.15. In the year 2007, what is the difference between the Cost of computers, communications and other services (% of commerical service exports) in Philippines and Cost of computers, communications and other services (% of commerical service exports) in Rwanda?
Your answer should be compact. 44.85. In the year 2008, what is the difference between the Cost of computers, communications and other services (% of commerical service exports) in Cameroon and Cost of computers, communications and other services (% of commerical service exports) in Philippines?
Keep it short and to the point. -26.14. In the year 2008, what is the difference between the Cost of computers, communications and other services (% of commerical service exports) in Cameroon and Cost of computers, communications and other services (% of commerical service exports) in Rwanda?
Offer a terse response. 41.63. In the year 2008, what is the difference between the Cost of computers, communications and other services (% of commerical service exports) in Philippines and Cost of computers, communications and other services (% of commerical service exports) in Rwanda?
Your response must be concise. 67.77. In the year 2009, what is the difference between the Cost of computers, communications and other services (% of commerical service exports) in Cameroon and Cost of computers, communications and other services (% of commerical service exports) in Philippines?
Keep it short and to the point. -46.37. In the year 2009, what is the difference between the Cost of computers, communications and other services (% of commerical service exports) of Cameroon and Cost of computers, communications and other services (% of commerical service exports) of Rwanda?
Offer a terse response. 21.06. In the year 2009, what is the difference between the Cost of computers, communications and other services (% of commerical service exports) of Philippines and Cost of computers, communications and other services (% of commerical service exports) of Rwanda?
Offer a terse response. 67.43. In the year 2010, what is the difference between the Cost of computers, communications and other services (% of commerical service exports) of Cameroon and Cost of computers, communications and other services (% of commerical service exports) of Philippines?
Your response must be concise. -31.9. In the year 2010, what is the difference between the Cost of computers, communications and other services (% of commerical service exports) of Cameroon and Cost of computers, communications and other services (% of commerical service exports) of Rwanda?
Provide a succinct answer. 34.09. In the year 2010, what is the difference between the Cost of computers, communications and other services (% of commerical service exports) in Philippines and Cost of computers, communications and other services (% of commerical service exports) in Rwanda?
Keep it short and to the point. 65.99. In the year 2011, what is the difference between the Cost of computers, communications and other services (% of commerical service exports) of Cameroon and Cost of computers, communications and other services (% of commerical service exports) of Philippines?
Make the answer very short. -30.24. In the year 2011, what is the difference between the Cost of computers, communications and other services (% of commerical service exports) in Cameroon and Cost of computers, communications and other services (% of commerical service exports) in Rwanda?
Keep it short and to the point. 25.93. In the year 2011, what is the difference between the Cost of computers, communications and other services (% of commerical service exports) of Philippines and Cost of computers, communications and other services (% of commerical service exports) of Rwanda?
Ensure brevity in your answer.  56.17. In the year 2012, what is the difference between the Cost of computers, communications and other services (% of commerical service exports) of Cameroon and Cost of computers, communications and other services (% of commerical service exports) of Philippines?
Make the answer very short. -33.96. In the year 2012, what is the difference between the Cost of computers, communications and other services (% of commerical service exports) of Cameroon and Cost of computers, communications and other services (% of commerical service exports) of Rwanda?
Provide a short and direct response. 32.86. In the year 2012, what is the difference between the Cost of computers, communications and other services (% of commerical service exports) of Philippines and Cost of computers, communications and other services (% of commerical service exports) of Rwanda?
Keep it short and to the point. 66.82. In the year 2013, what is the difference between the Cost of computers, communications and other services (% of commerical service exports) of Cameroon and Cost of computers, communications and other services (% of commerical service exports) of Philippines?
Your response must be concise. -39.04. In the year 2013, what is the difference between the Cost of computers, communications and other services (% of commerical service exports) of Cameroon and Cost of computers, communications and other services (% of commerical service exports) of Rwanda?
Provide a short and direct response. 20.05. In the year 2013, what is the difference between the Cost of computers, communications and other services (% of commerical service exports) of Philippines and Cost of computers, communications and other services (% of commerical service exports) of Rwanda?
Give a very brief answer. 59.09. What is the ratio of the Cost of computers, communications and other services (% of commerical service exports) in Cameroon in 2006 to that in 2007?
Provide a short and direct response. 0.79. What is the ratio of the Cost of computers, communications and other services (% of commerical service exports) in Philippines in 2006 to that in 2007?
Your response must be concise. 1.07. What is the ratio of the Cost of computers, communications and other services (% of commerical service exports) in Rwanda in 2006 to that in 2007?
Provide a short and direct response. 1.12. What is the ratio of the Cost of computers, communications and other services (% of commerical service exports) in Cameroon in 2006 to that in 2008?
Your answer should be compact. 0.51. What is the ratio of the Cost of computers, communications and other services (% of commerical service exports) in Philippines in 2006 to that in 2008?
Give a very brief answer. 0.83. What is the ratio of the Cost of computers, communications and other services (% of commerical service exports) of Rwanda in 2006 to that in 2008?
Your response must be concise. 5.83. What is the ratio of the Cost of computers, communications and other services (% of commerical service exports) of Cameroon in 2006 to that in 2009?
Your response must be concise. 0.79. What is the ratio of the Cost of computers, communications and other services (% of commerical service exports) in Philippines in 2006 to that in 2009?
Keep it short and to the point. 0.78. What is the ratio of the Cost of computers, communications and other services (% of commerical service exports) of Rwanda in 2006 to that in 2009?
Make the answer very short. 1.47. What is the ratio of the Cost of computers, communications and other services (% of commerical service exports) of Cameroon in 2006 to that in 2010?
Provide a succinct answer. 0.5. What is the ratio of the Cost of computers, communications and other services (% of commerical service exports) of Philippines in 2006 to that in 2010?
Your answer should be compact. 0.76. What is the ratio of the Cost of computers, communications and other services (% of commerical service exports) of Rwanda in 2006 to that in 2010?
Offer a terse response. 0.98. What is the ratio of the Cost of computers, communications and other services (% of commerical service exports) of Cameroon in 2006 to that in 2011?
Your answer should be very brief. 0.5. What is the ratio of the Cost of computers, communications and other services (% of commerical service exports) in Philippines in 2006 to that in 2011?
Your answer should be very brief. 0.78. What is the ratio of the Cost of computers, communications and other services (% of commerical service exports) in Rwanda in 2006 to that in 2011?
Offer a very short reply. 0.56. What is the ratio of the Cost of computers, communications and other services (% of commerical service exports) of Cameroon in 2006 to that in 2012?
Make the answer very short. 0.59. What is the ratio of the Cost of computers, communications and other services (% of commerical service exports) in Philippines in 2006 to that in 2012?
Offer a terse response. 0.81. What is the ratio of the Cost of computers, communications and other services (% of commerical service exports) in Rwanda in 2006 to that in 2012?
Your answer should be very brief. 2.22. What is the ratio of the Cost of computers, communications and other services (% of commerical service exports) of Cameroon in 2006 to that in 2013?
Give a very brief answer. 0.68. What is the ratio of the Cost of computers, communications and other services (% of commerical service exports) of Philippines in 2006 to that in 2013?
Make the answer very short. 0.8. What is the ratio of the Cost of computers, communications and other services (% of commerical service exports) in Rwanda in 2006 to that in 2013?
Offer a very short reply. 0.79. What is the ratio of the Cost of computers, communications and other services (% of commerical service exports) in Cameroon in 2007 to that in 2008?
Ensure brevity in your answer.  0.65. What is the ratio of the Cost of computers, communications and other services (% of commerical service exports) of Philippines in 2007 to that in 2008?
Your answer should be compact. 0.78. What is the ratio of the Cost of computers, communications and other services (% of commerical service exports) of Rwanda in 2007 to that in 2008?
Offer a very short reply. 5.2. What is the ratio of the Cost of computers, communications and other services (% of commerical service exports) of Cameroon in 2007 to that in 2009?
Your answer should be compact. 1.01. What is the ratio of the Cost of computers, communications and other services (% of commerical service exports) in Philippines in 2007 to that in 2009?
Ensure brevity in your answer.  0.73. What is the ratio of the Cost of computers, communications and other services (% of commerical service exports) in Rwanda in 2007 to that in 2009?
Your answer should be very brief. 1.31. What is the ratio of the Cost of computers, communications and other services (% of commerical service exports) in Cameroon in 2007 to that in 2010?
Offer a terse response. 0.64. What is the ratio of the Cost of computers, communications and other services (% of commerical service exports) of Philippines in 2007 to that in 2010?
Offer a terse response. 0.71. What is the ratio of the Cost of computers, communications and other services (% of commerical service exports) of Rwanda in 2007 to that in 2010?
Keep it short and to the point. 0.87. What is the ratio of the Cost of computers, communications and other services (% of commerical service exports) of Cameroon in 2007 to that in 2011?
Your answer should be very brief. 0.64. What is the ratio of the Cost of computers, communications and other services (% of commerical service exports) of Philippines in 2007 to that in 2011?
Offer a very short reply. 0.72. What is the ratio of the Cost of computers, communications and other services (% of commerical service exports) of Rwanda in 2007 to that in 2011?
Provide a succinct answer. 0.5. What is the ratio of the Cost of computers, communications and other services (% of commerical service exports) of Cameroon in 2007 to that in 2012?
Offer a very short reply. 0.76. What is the ratio of the Cost of computers, communications and other services (% of commerical service exports) in Philippines in 2007 to that in 2012?
Provide a short and direct response. 0.76. What is the ratio of the Cost of computers, communications and other services (% of commerical service exports) of Rwanda in 2007 to that in 2012?
Offer a terse response. 1.98. What is the ratio of the Cost of computers, communications and other services (% of commerical service exports) of Cameroon in 2007 to that in 2013?
Offer a terse response. 0.86. What is the ratio of the Cost of computers, communications and other services (% of commerical service exports) of Philippines in 2007 to that in 2013?
Give a very brief answer. 0.75. What is the ratio of the Cost of computers, communications and other services (% of commerical service exports) of Rwanda in 2007 to that in 2013?
Give a very brief answer. 0.71. What is the ratio of the Cost of computers, communications and other services (% of commerical service exports) in Cameroon in 2008 to that in 2009?
Provide a short and direct response. 1.55. What is the ratio of the Cost of computers, communications and other services (% of commerical service exports) in Philippines in 2008 to that in 2009?
Offer a terse response. 0.93. What is the ratio of the Cost of computers, communications and other services (% of commerical service exports) of Rwanda in 2008 to that in 2009?
Your answer should be very brief. 0.25. What is the ratio of the Cost of computers, communications and other services (% of commerical service exports) in Cameroon in 2008 to that in 2010?
Your answer should be compact. 0.97. What is the ratio of the Cost of computers, communications and other services (% of commerical service exports) in Philippines in 2008 to that in 2010?
Your response must be concise. 0.91. What is the ratio of the Cost of computers, communications and other services (% of commerical service exports) of Rwanda in 2008 to that in 2010?
Provide a short and direct response. 0.17. What is the ratio of the Cost of computers, communications and other services (% of commerical service exports) of Cameroon in 2008 to that in 2011?
Provide a short and direct response. 0.98. What is the ratio of the Cost of computers, communications and other services (% of commerical service exports) in Philippines in 2008 to that in 2011?
Provide a short and direct response. 0.93. What is the ratio of the Cost of computers, communications and other services (% of commerical service exports) in Rwanda in 2008 to that in 2011?
Provide a short and direct response. 0.1. What is the ratio of the Cost of computers, communications and other services (% of commerical service exports) in Cameroon in 2008 to that in 2012?
Offer a very short reply. 1.16. What is the ratio of the Cost of computers, communications and other services (% of commerical service exports) in Philippines in 2008 to that in 2012?
Ensure brevity in your answer.  0.97. What is the ratio of the Cost of computers, communications and other services (% of commerical service exports) of Rwanda in 2008 to that in 2012?
Keep it short and to the point. 0.38. What is the ratio of the Cost of computers, communications and other services (% of commerical service exports) in Cameroon in 2008 to that in 2013?
Keep it short and to the point. 1.31. What is the ratio of the Cost of computers, communications and other services (% of commerical service exports) in Philippines in 2008 to that in 2013?
Provide a succinct answer. 0.96. What is the ratio of the Cost of computers, communications and other services (% of commerical service exports) of Rwanda in 2008 to that in 2013?
Your response must be concise. 0.14. What is the ratio of the Cost of computers, communications and other services (% of commerical service exports) in Cameroon in 2009 to that in 2010?
Your answer should be compact. 0.63. What is the ratio of the Cost of computers, communications and other services (% of commerical service exports) of Philippines in 2009 to that in 2010?
Provide a short and direct response. 0.97. What is the ratio of the Cost of computers, communications and other services (% of commerical service exports) in Rwanda in 2009 to that in 2010?
Provide a short and direct response. 0.67. What is the ratio of the Cost of computers, communications and other services (% of commerical service exports) in Cameroon in 2009 to that in 2011?
Your response must be concise. 0.63. What is the ratio of the Cost of computers, communications and other services (% of commerical service exports) of Philippines in 2009 to that in 2011?
Offer a terse response. 1. What is the ratio of the Cost of computers, communications and other services (% of commerical service exports) in Rwanda in 2009 to that in 2011?
Ensure brevity in your answer.  0.38. What is the ratio of the Cost of computers, communications and other services (% of commerical service exports) of Cameroon in 2009 to that in 2012?
Offer a very short reply. 0.75. What is the ratio of the Cost of computers, communications and other services (% of commerical service exports) of Philippines in 2009 to that in 2012?
Your answer should be compact. 1.04. What is the ratio of the Cost of computers, communications and other services (% of commerical service exports) of Rwanda in 2009 to that in 2012?
Make the answer very short. 1.51. What is the ratio of the Cost of computers, communications and other services (% of commerical service exports) in Cameroon in 2009 to that in 2013?
Keep it short and to the point. 0.85. What is the ratio of the Cost of computers, communications and other services (% of commerical service exports) in Philippines in 2009 to that in 2013?
Your response must be concise. 1.03. What is the ratio of the Cost of computers, communications and other services (% of commerical service exports) of Rwanda in 2009 to that in 2013?
Provide a succinct answer. 0.54. What is the ratio of the Cost of computers, communications and other services (% of commerical service exports) of Philippines in 2010 to that in 2011?
Give a very brief answer. 1.03. What is the ratio of the Cost of computers, communications and other services (% of commerical service exports) of Rwanda in 2010 to that in 2011?
Your answer should be very brief. 0.57. What is the ratio of the Cost of computers, communications and other services (% of commerical service exports) in Cameroon in 2010 to that in 2012?
Give a very brief answer. 1.19. What is the ratio of the Cost of computers, communications and other services (% of commerical service exports) of Philippines in 2010 to that in 2012?
Provide a short and direct response. 1.07. What is the ratio of the Cost of computers, communications and other services (% of commerical service exports) of Rwanda in 2010 to that in 2012?
Give a very brief answer. 2.27. What is the ratio of the Cost of computers, communications and other services (% of commerical service exports) in Cameroon in 2010 to that in 2013?
Make the answer very short. 1.35. What is the ratio of the Cost of computers, communications and other services (% of commerical service exports) in Philippines in 2010 to that in 2013?
Your answer should be compact. 1.06. What is the ratio of the Cost of computers, communications and other services (% of commerical service exports) of Rwanda in 2010 to that in 2013?
Keep it short and to the point. 0.81. What is the ratio of the Cost of computers, communications and other services (% of commerical service exports) in Cameroon in 2011 to that in 2012?
Ensure brevity in your answer.  1.18. What is the ratio of the Cost of computers, communications and other services (% of commerical service exports) in Philippines in 2011 to that in 2012?
Your answer should be very brief. 1.04. What is the ratio of the Cost of computers, communications and other services (% of commerical service exports) of Rwanda in 2011 to that in 2012?
Keep it short and to the point. 3.97. What is the ratio of the Cost of computers, communications and other services (% of commerical service exports) of Cameroon in 2011 to that in 2013?
Your answer should be very brief. 1.34. What is the ratio of the Cost of computers, communications and other services (% of commerical service exports) in Philippines in 2011 to that in 2013?
Your response must be concise. 1.03. What is the ratio of the Cost of computers, communications and other services (% of commerical service exports) of Rwanda in 2011 to that in 2013?
Keep it short and to the point. 1.42. What is the ratio of the Cost of computers, communications and other services (% of commerical service exports) of Cameroon in 2012 to that in 2013?
Your response must be concise. 1.13. What is the ratio of the Cost of computers, communications and other services (% of commerical service exports) in Rwanda in 2012 to that in 2013?
Ensure brevity in your answer.  0.36. What is the difference between the highest and the second highest Cost of computers, communications and other services (% of commerical service exports) in Cameroon?
Ensure brevity in your answer.  0.29. What is the difference between the highest and the second highest Cost of computers, communications and other services (% of commerical service exports) in Philippines?
Provide a short and direct response. 1.95. What is the difference between the highest and the second highest Cost of computers, communications and other services (% of commerical service exports) in Rwanda?
Offer a very short reply. 5.4. What is the difference between the highest and the lowest Cost of computers, communications and other services (% of commerical service exports) in Cameroon?
Give a very brief answer. 22.3. What is the difference between the highest and the lowest Cost of computers, communications and other services (% of commerical service exports) in Philippines?
Offer a terse response. 22.46. What is the difference between the highest and the lowest Cost of computers, communications and other services (% of commerical service exports) in Rwanda?
Give a very brief answer. 16.62. 